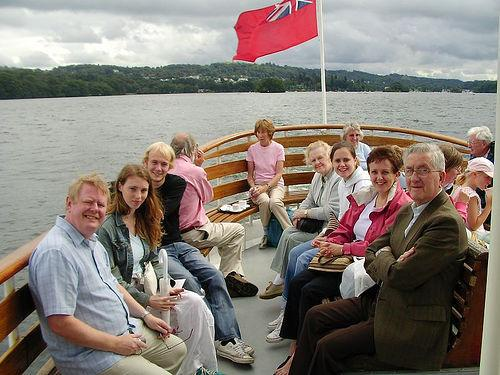What group of people are they likely to be?

Choices:
A) americans
B) russians
C) europeans
D) australians europeans 